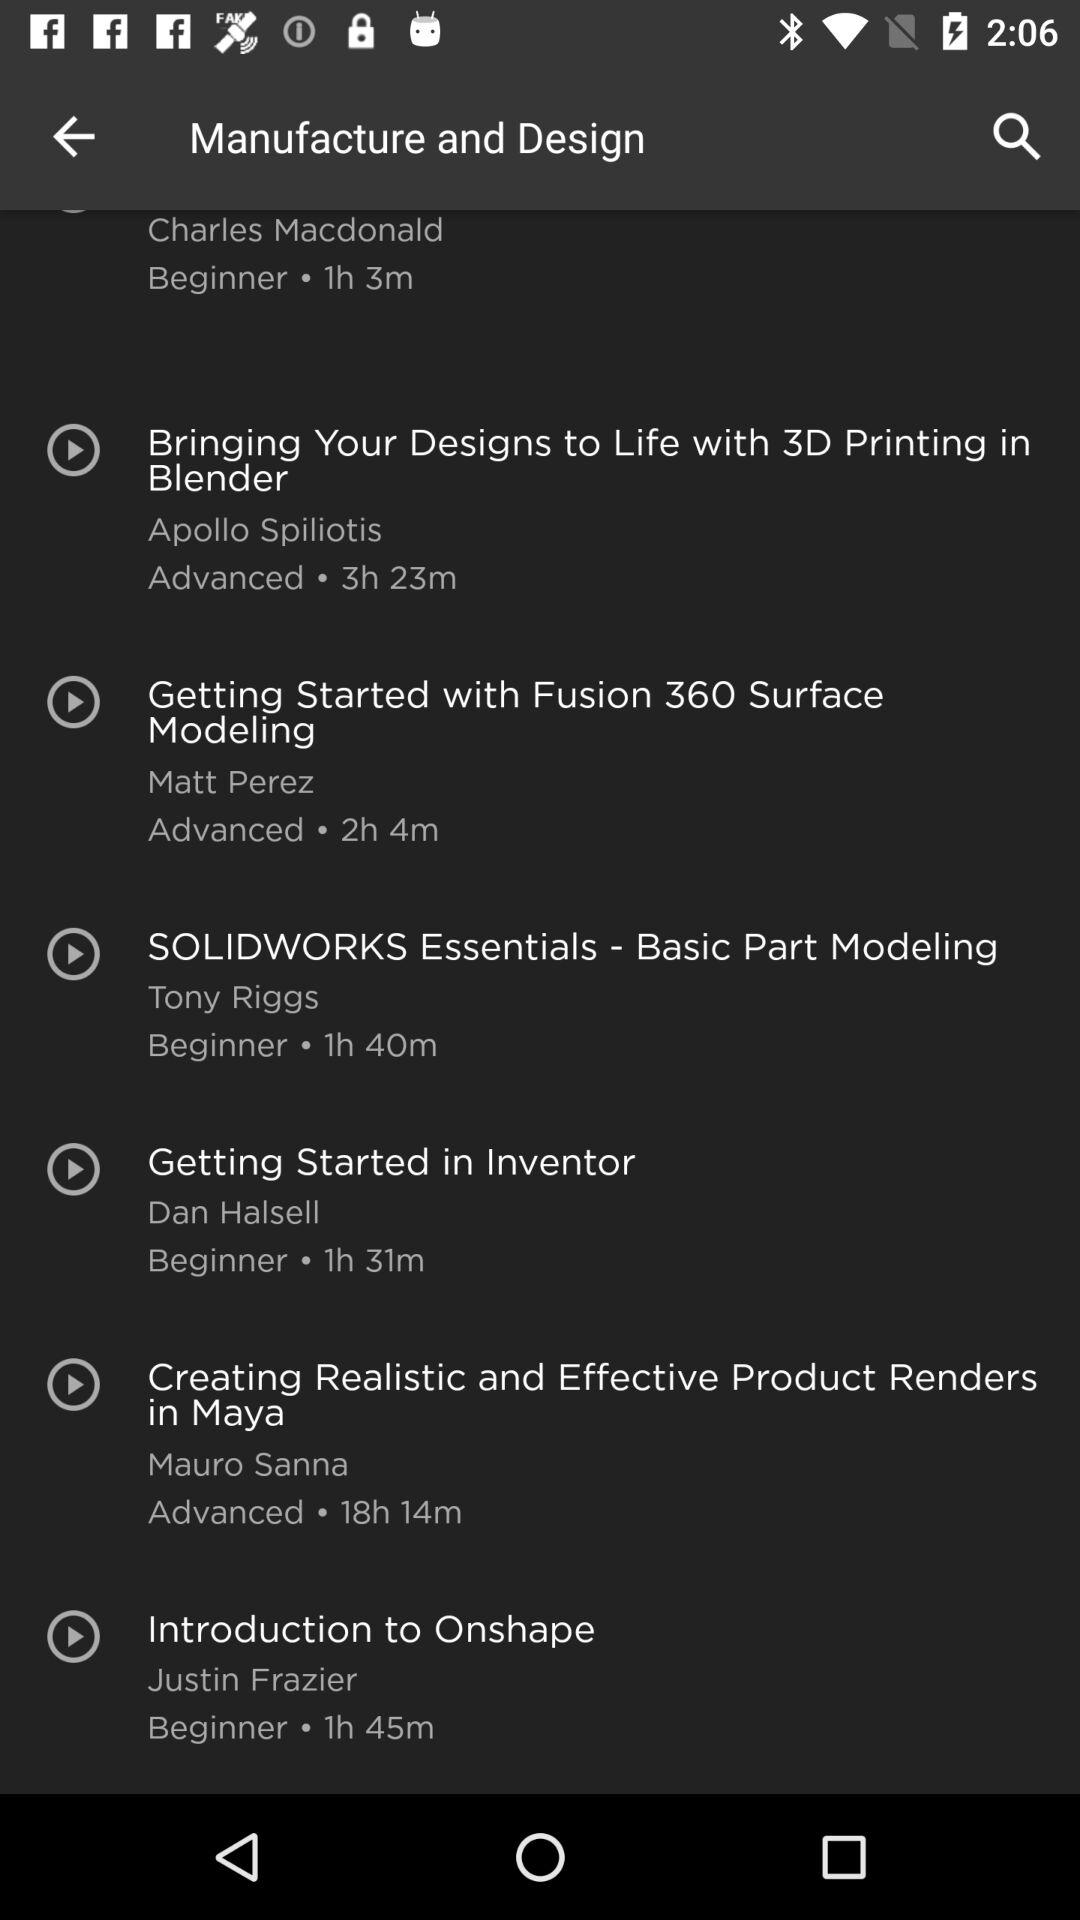Who is "Introduction to Onshape" intended for? "Introduction to Onshape" is intended for beginners. 